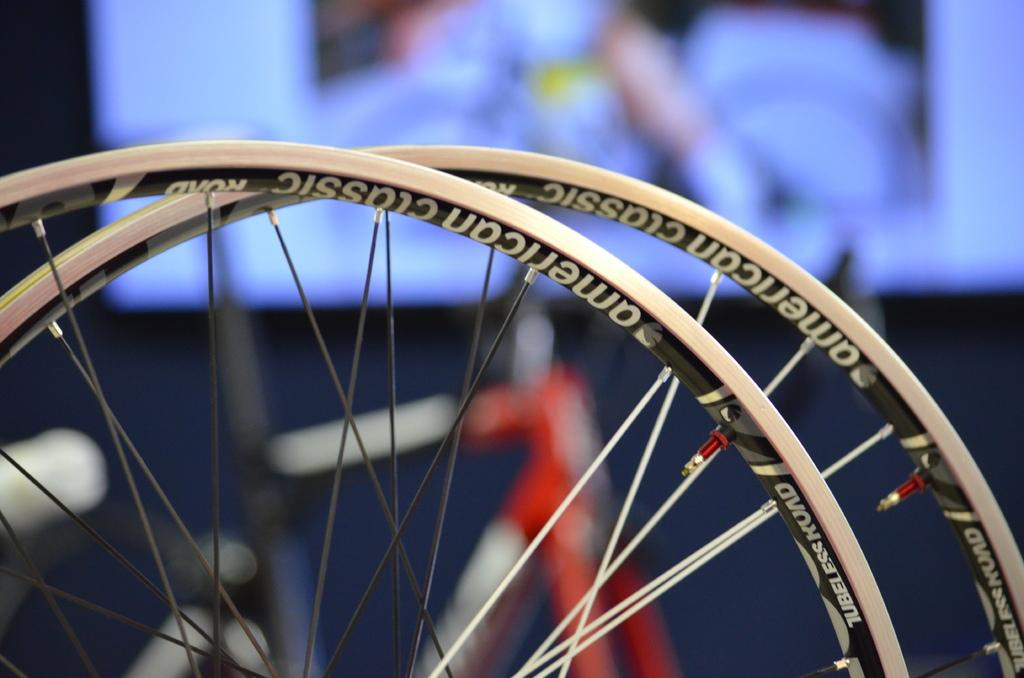What is the main subject of the image? The main subject of the image is two cycle tires. Are there any specific details about the cycle tires? Yes, there is writing on the cycle tires. What can be seen in the background of the image? There is a screen in the background of the image. How many pages of the book can be seen in the image? There is no book present in the image, so it is not possible to determine the number of pages. 